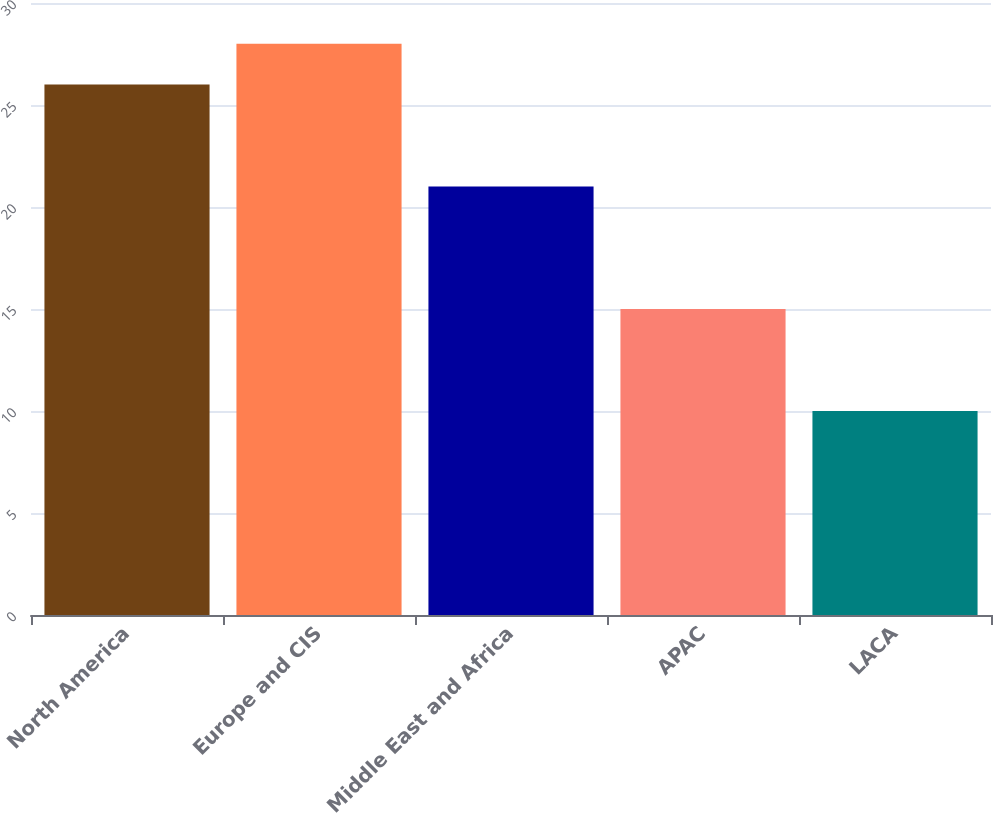Convert chart. <chart><loc_0><loc_0><loc_500><loc_500><bar_chart><fcel>North America<fcel>Europe and CIS<fcel>Middle East and Africa<fcel>APAC<fcel>LACA<nl><fcel>26<fcel>28<fcel>21<fcel>15<fcel>10<nl></chart> 